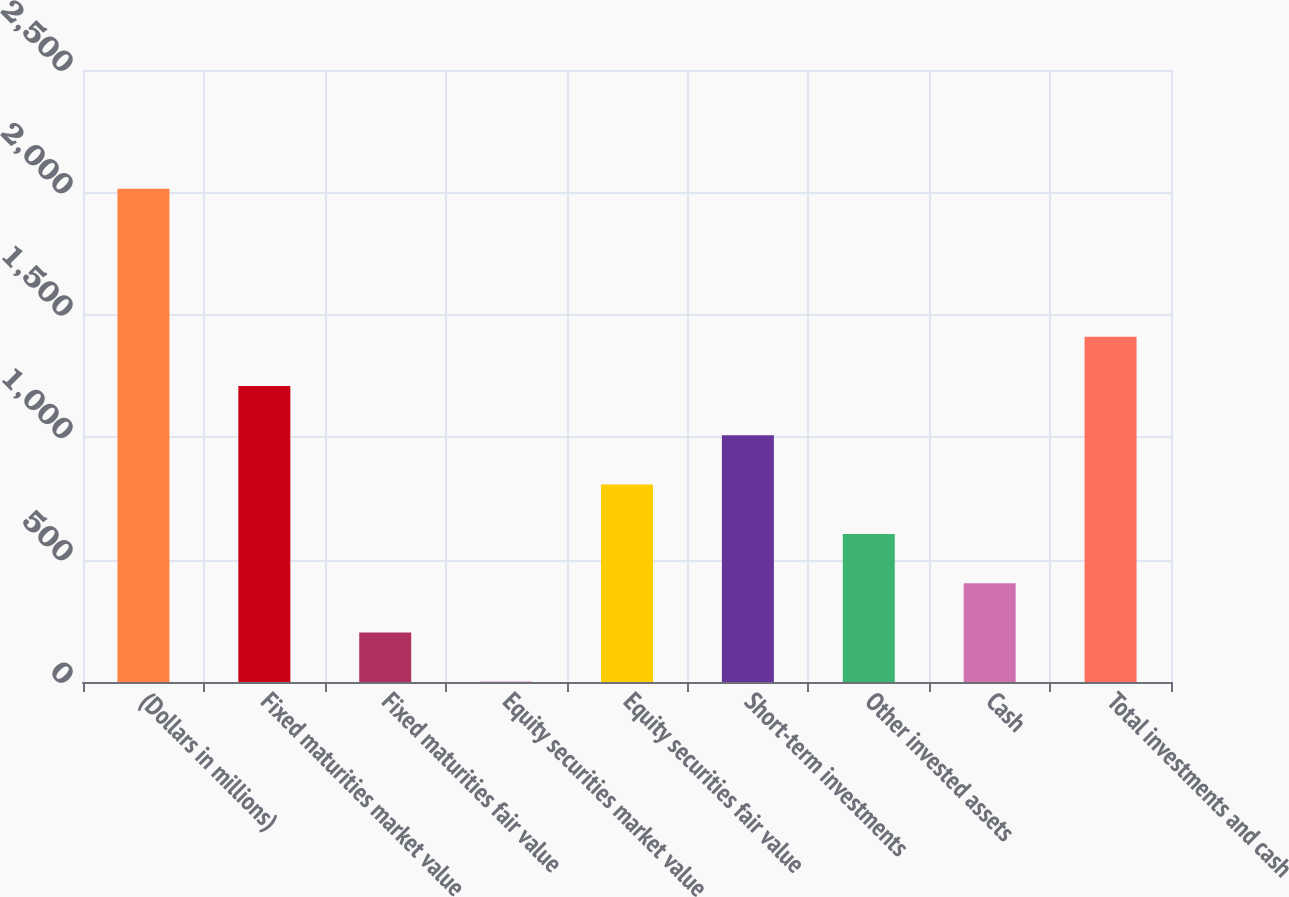<chart> <loc_0><loc_0><loc_500><loc_500><bar_chart><fcel>(Dollars in millions)<fcel>Fixed maturities market value<fcel>Fixed maturities fair value<fcel>Equity securities market value<fcel>Equity securities fair value<fcel>Short-term investments<fcel>Other invested assets<fcel>Cash<fcel>Total investments and cash<nl><fcel>2015<fcel>1209.24<fcel>202.04<fcel>0.6<fcel>806.36<fcel>1007.8<fcel>604.92<fcel>403.48<fcel>1410.68<nl></chart> 